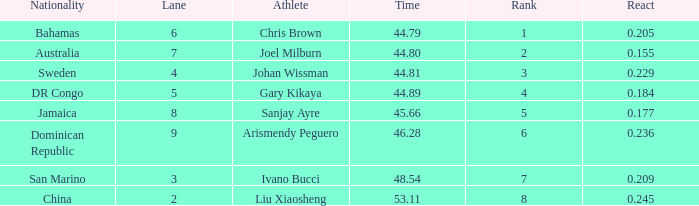What Lane has a 0.209 React entered with a Rank entry that is larger than 6? 2.0. I'm looking to parse the entire table for insights. Could you assist me with that? {'header': ['Nationality', 'Lane', 'Athlete', 'Time', 'Rank', 'React'], 'rows': [['Bahamas', '6', 'Chris Brown', '44.79', '1', '0.205'], ['Australia', '7', 'Joel Milburn', '44.80', '2', '0.155'], ['Sweden', '4', 'Johan Wissman', '44.81', '3', '0.229'], ['DR Congo', '5', 'Gary Kikaya', '44.89', '4', '0.184'], ['Jamaica', '8', 'Sanjay Ayre', '45.66', '5', '0.177'], ['Dominican Republic', '9', 'Arismendy Peguero', '46.28', '6', '0.236'], ['San Marino', '3', 'Ivano Bucci', '48.54', '7', '0.209'], ['China', '2', 'Liu Xiaosheng', '53.11', '8', '0.245']]} 